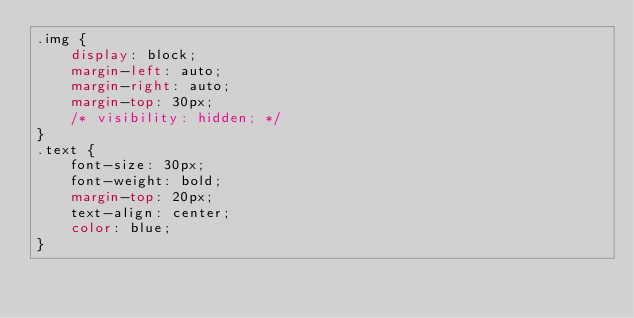<code> <loc_0><loc_0><loc_500><loc_500><_CSS_>.img {
    display: block;
    margin-left: auto;
    margin-right: auto;
    margin-top: 30px;
    /* visibility: hidden; */
}
.text {
    font-size: 30px;
    font-weight: bold;
    margin-top: 20px;
    text-align: center;
    color: blue;
}
</code> 